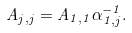Convert formula to latex. <formula><loc_0><loc_0><loc_500><loc_500>A _ { j , j } = A _ { 1 , 1 } \alpha _ { 1 , j } ^ { - 1 } .</formula> 